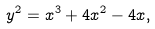Convert formula to latex. <formula><loc_0><loc_0><loc_500><loc_500>y ^ { 2 } = x ^ { 3 } + 4 x ^ { 2 } - 4 x ,</formula> 